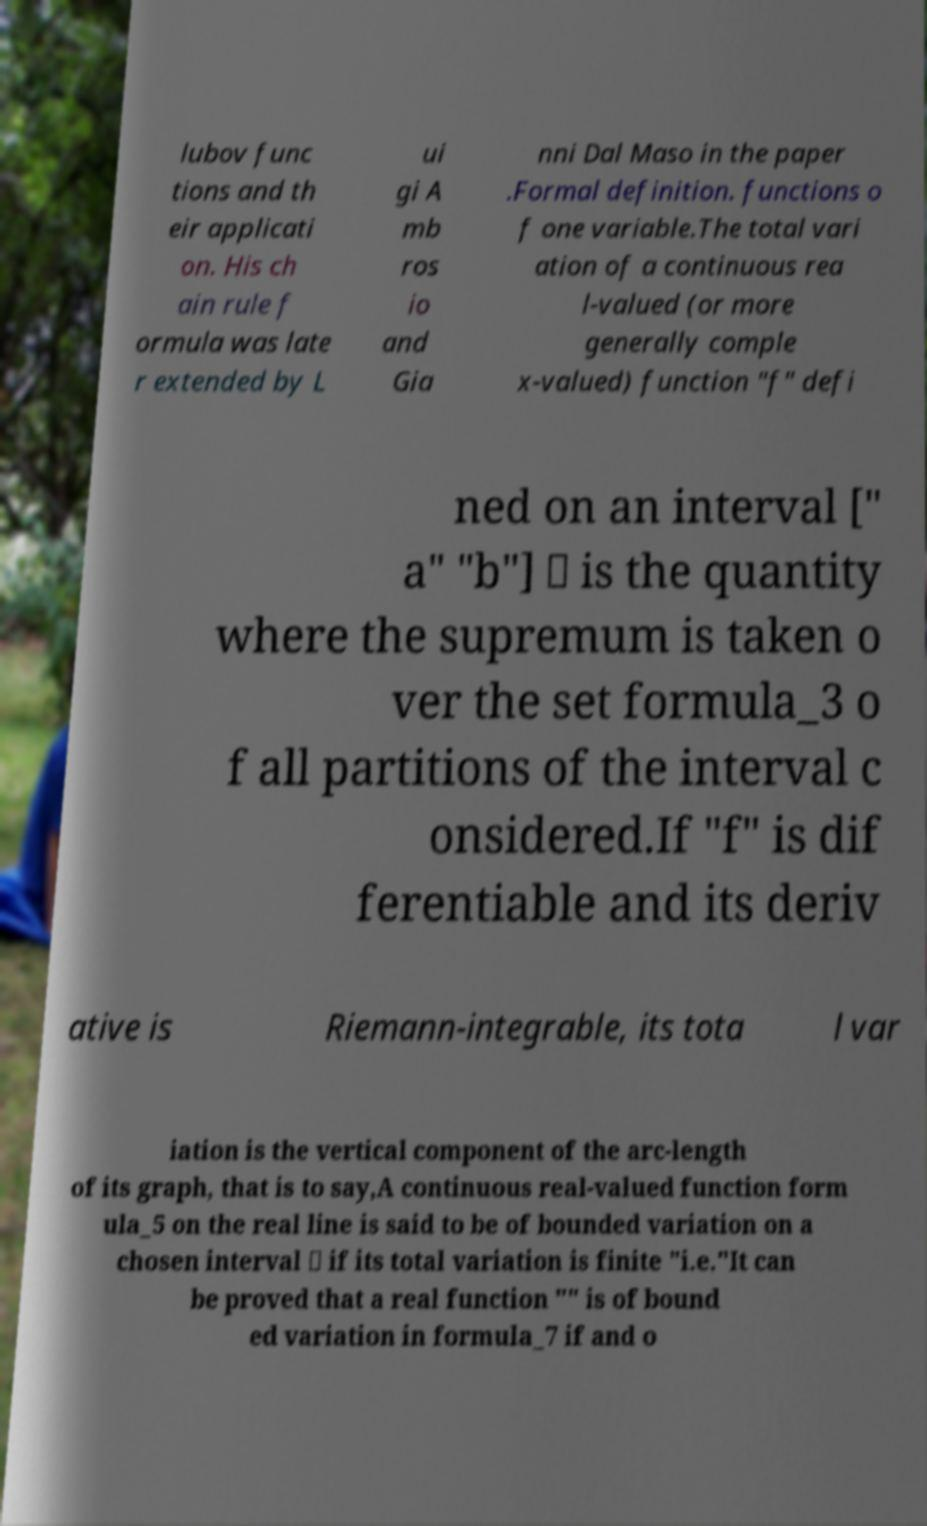For documentation purposes, I need the text within this image transcribed. Could you provide that? lubov func tions and th eir applicati on. His ch ain rule f ormula was late r extended by L ui gi A mb ros io and Gia nni Dal Maso in the paper .Formal definition. functions o f one variable.The total vari ation of a continuous rea l-valued (or more generally comple x-valued) function "f" defi ned on an interval [" a" "b"] ⊂ is the quantity where the supremum is taken o ver the set formula_3 o f all partitions of the interval c onsidered.If "f" is dif ferentiable and its deriv ative is Riemann-integrable, its tota l var iation is the vertical component of the arc-length of its graph, that is to say,A continuous real-valued function form ula_5 on the real line is said to be of bounded variation on a chosen interval ⊂ if its total variation is finite "i.e."It can be proved that a real function "" is of bound ed variation in formula_7 if and o 